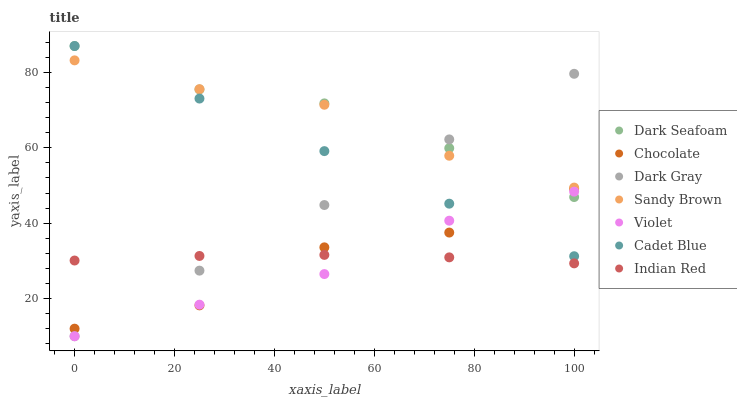Does Violet have the minimum area under the curve?
Answer yes or no. Yes. Does Dark Seafoam have the maximum area under the curve?
Answer yes or no. Yes. Does Chocolate have the minimum area under the curve?
Answer yes or no. No. Does Chocolate have the maximum area under the curve?
Answer yes or no. No. Is Dark Gray the smoothest?
Answer yes or no. Yes. Is Chocolate the roughest?
Answer yes or no. Yes. Is Chocolate the smoothest?
Answer yes or no. No. Is Dark Gray the roughest?
Answer yes or no. No. Does Dark Gray have the lowest value?
Answer yes or no. Yes. Does Chocolate have the lowest value?
Answer yes or no. No. Does Dark Seafoam have the highest value?
Answer yes or no. Yes. Does Chocolate have the highest value?
Answer yes or no. No. Is Indian Red less than Dark Seafoam?
Answer yes or no. Yes. Is Cadet Blue greater than Indian Red?
Answer yes or no. Yes. Does Chocolate intersect Violet?
Answer yes or no. Yes. Is Chocolate less than Violet?
Answer yes or no. No. Is Chocolate greater than Violet?
Answer yes or no. No. Does Indian Red intersect Dark Seafoam?
Answer yes or no. No. 